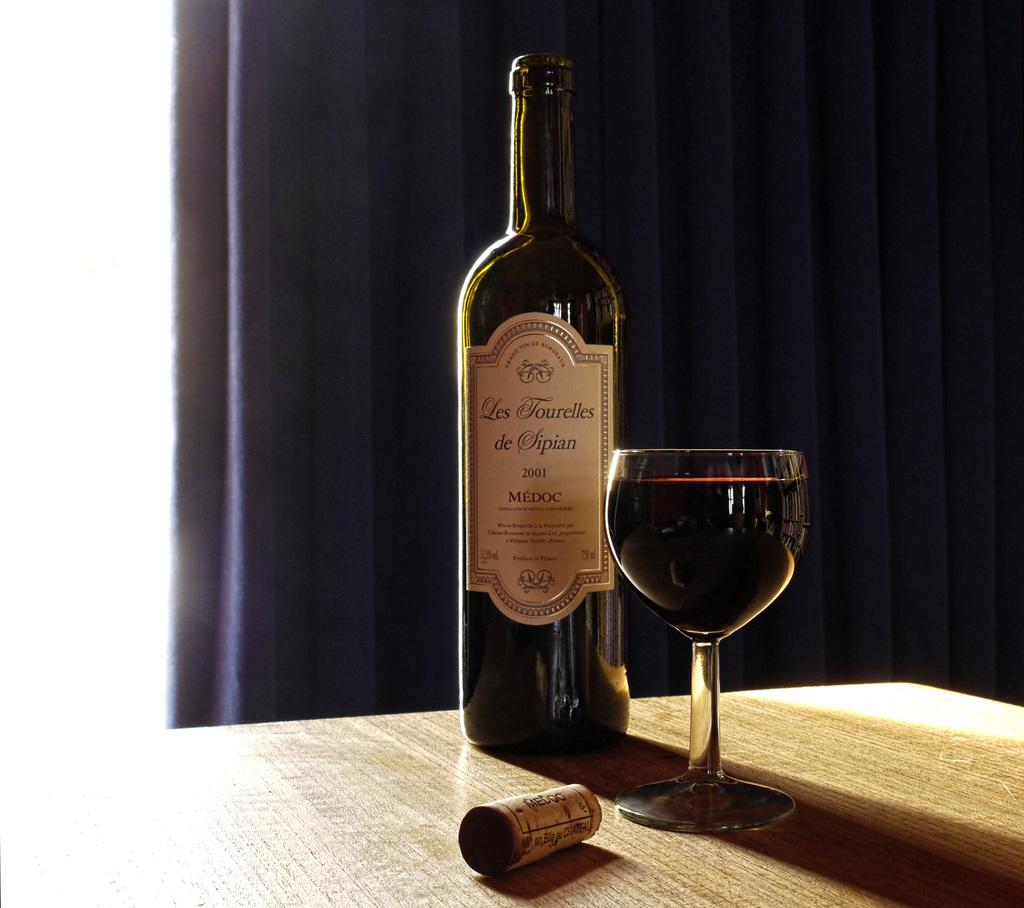What is the year of the wine?
Your answer should be very brief. 2001. 